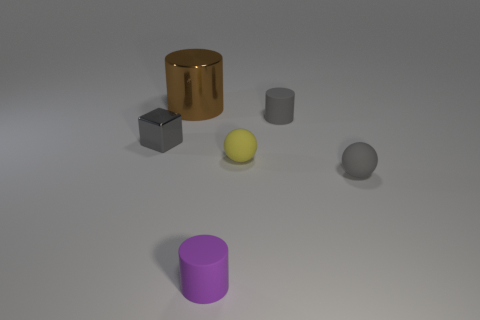Subtract all rubber cylinders. How many cylinders are left? 1 Add 4 yellow objects. How many objects exist? 10 Subtract 1 cylinders. How many cylinders are left? 2 Subtract all cyan cylinders. Subtract all gray blocks. How many cylinders are left? 3 Subtract all spheres. How many objects are left? 4 Add 6 tiny purple cylinders. How many tiny purple cylinders are left? 7 Add 4 large brown metal objects. How many large brown metal objects exist? 5 Subtract 1 gray spheres. How many objects are left? 5 Subtract all small gray rubber things. Subtract all cyan blocks. How many objects are left? 4 